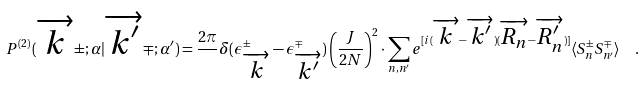<formula> <loc_0><loc_0><loc_500><loc_500>P ^ { ( 2 ) } ( \overrightarrow { k } \pm ; \alpha | \overrightarrow { k ^ { \prime } } \mp ; \alpha ^ { \prime } ) = \frac { 2 \pi } { } \delta ( \epsilon _ { \overrightarrow { k } } ^ { \pm } - \epsilon _ { \overrightarrow { k ^ { \prime } } } ^ { \mp } ) \left ( \frac { J } { 2 N } \right ) ^ { 2 } \cdot \sum _ { n , n ^ { \prime } } e ^ { [ i ( \overrightarrow { k } - \overrightarrow { k ^ { \prime } } ) ( \overrightarrow { R _ { n } } - \overrightarrow { R _ { n } ^ { \prime } } ) ] } \langle S _ { n } ^ { \pm } S _ { n ^ { \prime } } ^ { \mp } \rangle \ \ .</formula> 